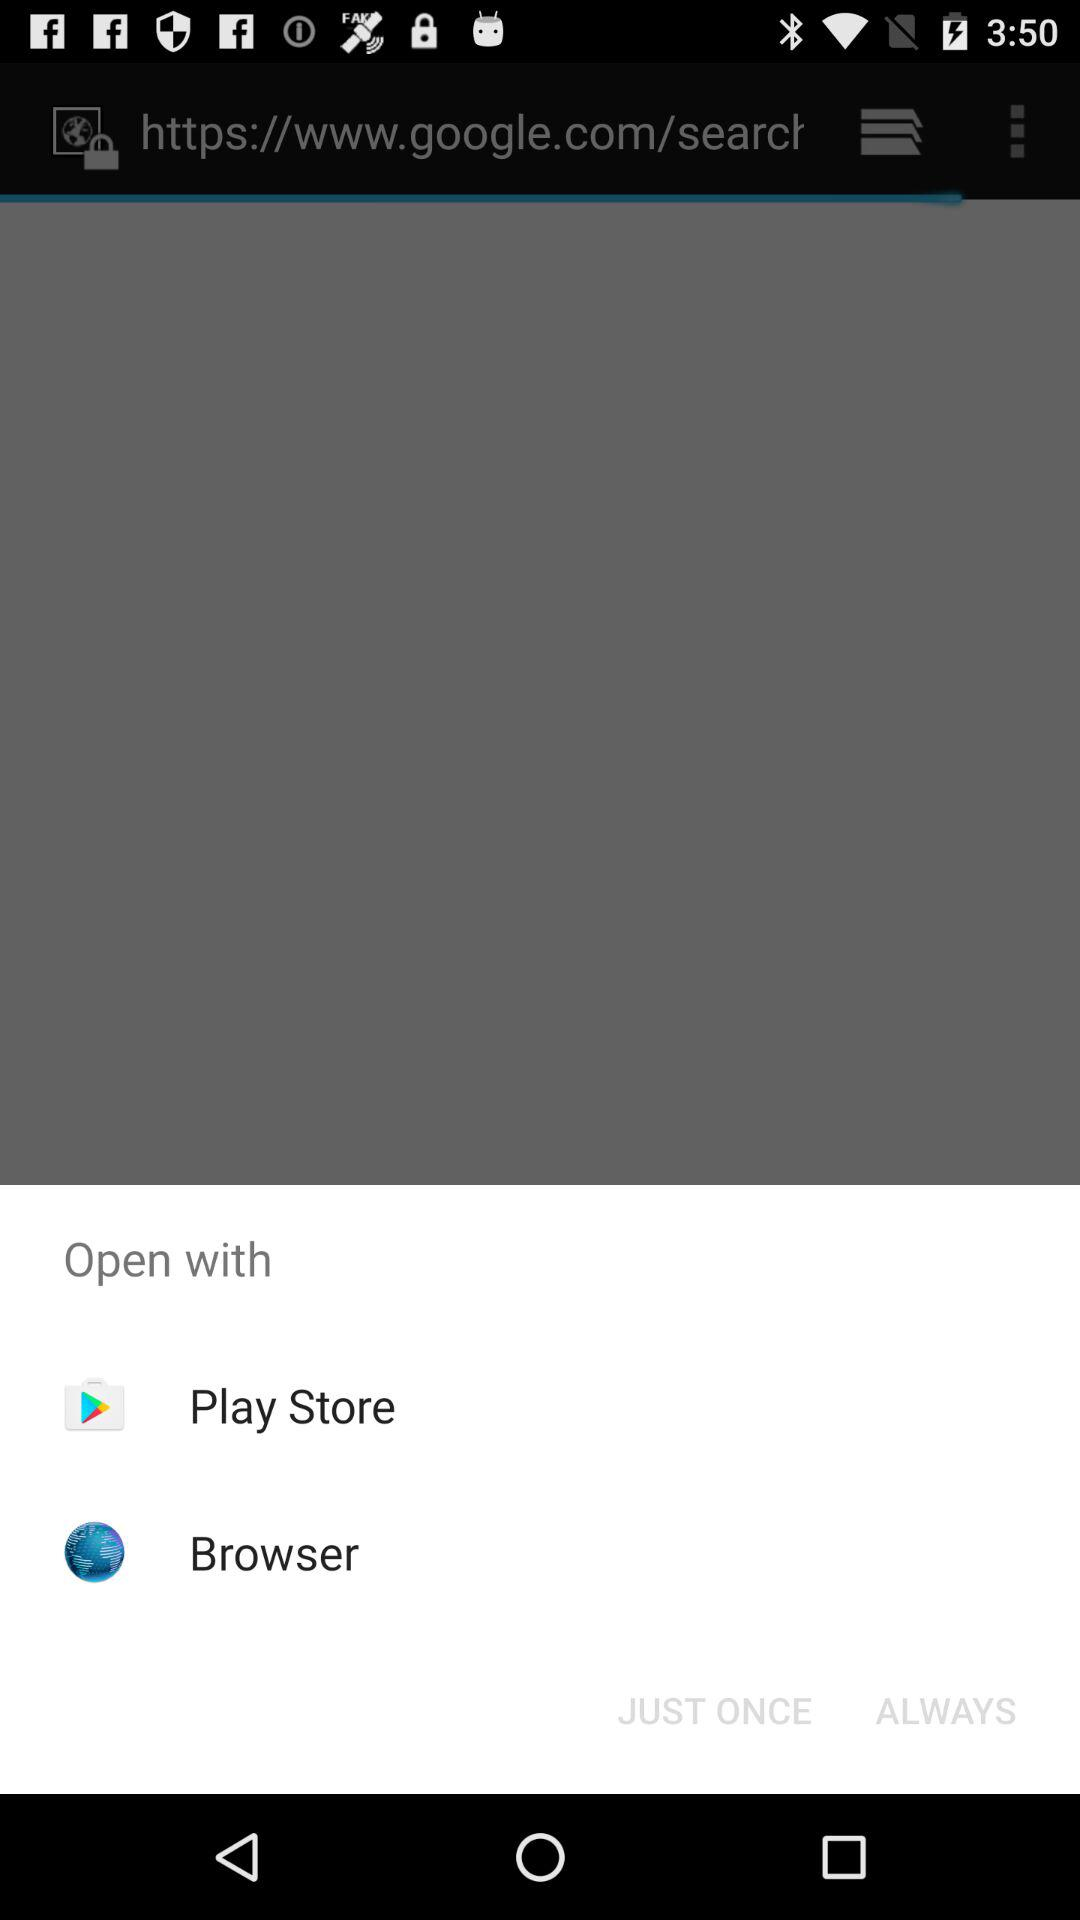What are the options to open? The options to open are "Play Store" and "Browser". 